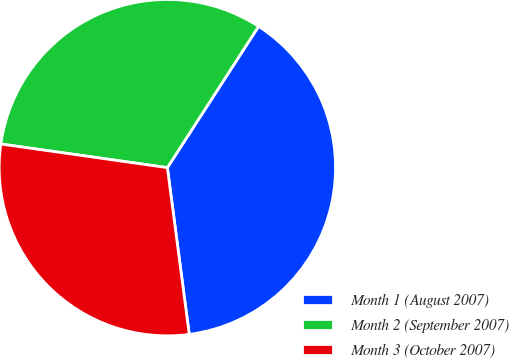Convert chart to OTSL. <chart><loc_0><loc_0><loc_500><loc_500><pie_chart><fcel>Month 1 (August 2007)<fcel>Month 2 (September 2007)<fcel>Month 3 (October 2007)<nl><fcel>38.8%<fcel>31.88%<fcel>29.32%<nl></chart> 